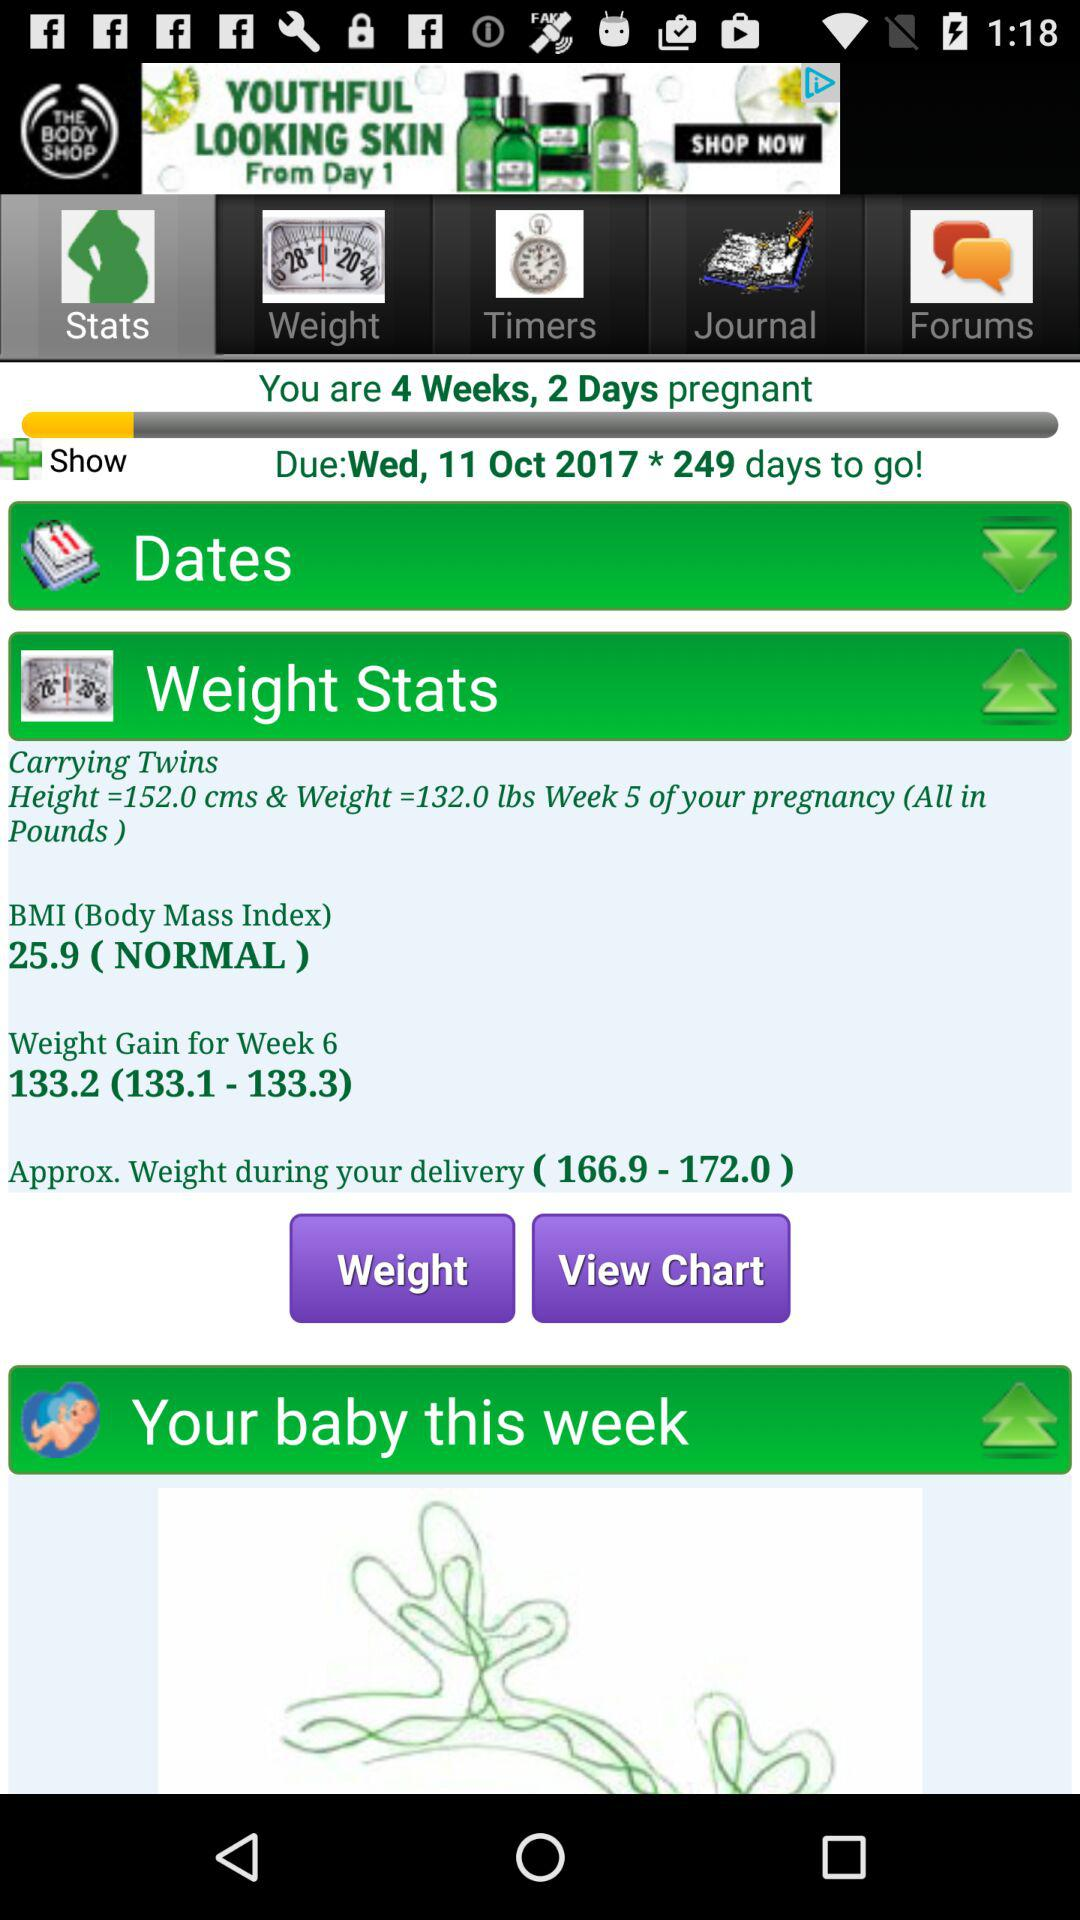How many weeks and days am I pregnant? You are 4 weeks and 2 days pregnant. 